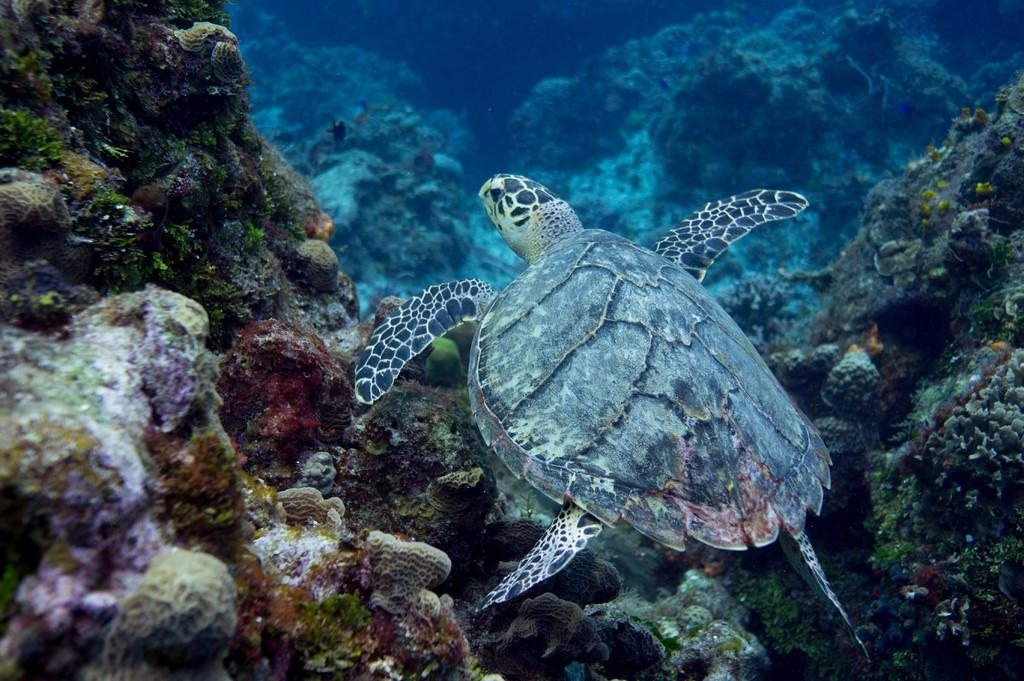What type of animal is in the image? There is a tortoise in the image. What is the tortoise situated in? The tortoise is in the water in the image. What else can be seen in the water? There are rocks in the water in the image. What type of shoes are the tortoise's toes wearing in the image? There are no shoes or toes mentioned in the image, as it features a tortoise in the water with rocks. 